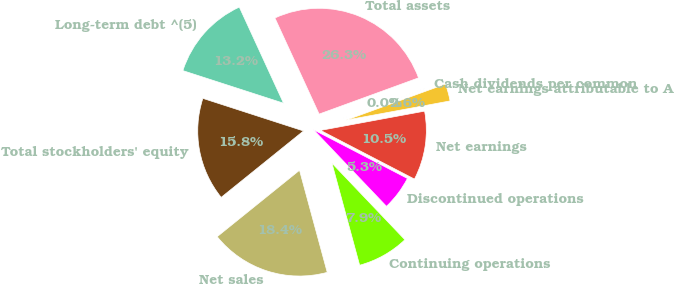Convert chart. <chart><loc_0><loc_0><loc_500><loc_500><pie_chart><fcel>Net sales<fcel>Continuing operations<fcel>Discontinued operations<fcel>Net earnings<fcel>Net earnings attributable to A<fcel>Cash dividends per common<fcel>Total assets<fcel>Long-term debt ^(5)<fcel>Total stockholders' equity<nl><fcel>18.42%<fcel>7.9%<fcel>5.27%<fcel>10.53%<fcel>2.64%<fcel>0.01%<fcel>26.31%<fcel>13.16%<fcel>15.79%<nl></chart> 